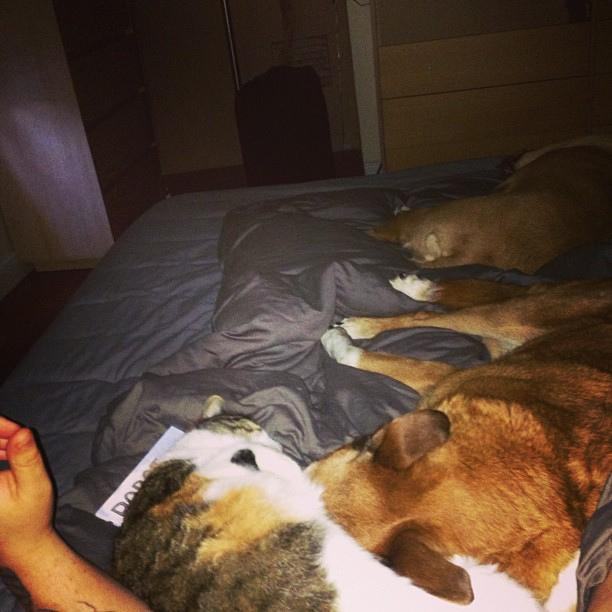The cat is cozying up to what animal?

Choices:
A) pig
B) cow
C) dog
D) goat dog 